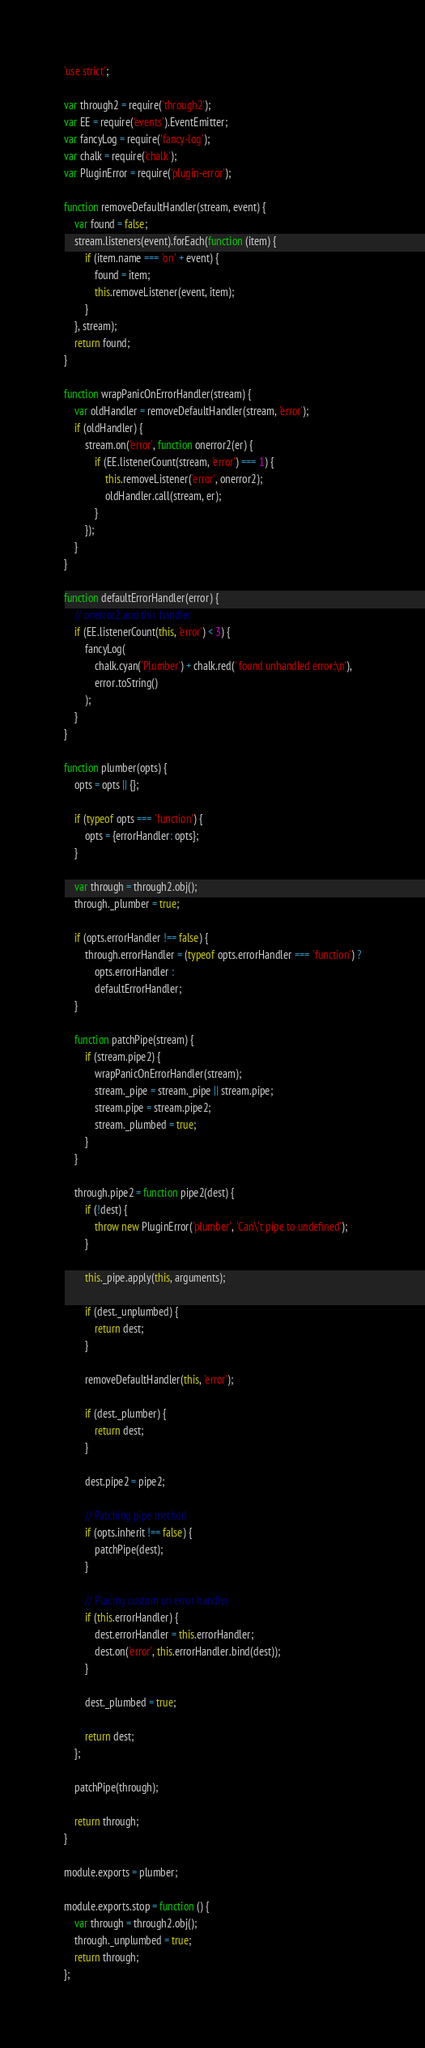Convert code to text. <code><loc_0><loc_0><loc_500><loc_500><_JavaScript_>'use strict';

var through2 = require('through2');
var EE = require('events').EventEmitter;
var fancyLog = require('fancy-log');
var chalk = require('chalk');
var PluginError = require('plugin-error');

function removeDefaultHandler(stream, event) {
	var found = false;
	stream.listeners(event).forEach(function (item) {
		if (item.name === 'on' + event) {
			found = item;
			this.removeListener(event, item);
		}
	}, stream);
	return found;
}

function wrapPanicOnErrorHandler(stream) {
	var oldHandler = removeDefaultHandler(stream, 'error');
	if (oldHandler) {
		stream.on('error', function onerror2(er) {
			if (EE.listenerCount(stream, 'error') === 1) {
				this.removeListener('error', onerror2);
				oldHandler.call(stream, er);
			}
		});
	}
}

function defaultErrorHandler(error) {
	// onerror2 and this handler
	if (EE.listenerCount(this, 'error') < 3) {
		fancyLog(
			chalk.cyan('Plumber') + chalk.red(' found unhandled error:\n'),
			error.toString()
		);
	}
}

function plumber(opts) {
	opts = opts || {};

	if (typeof opts === 'function') {
		opts = {errorHandler: opts};
	}

	var through = through2.obj();
	through._plumber = true;

	if (opts.errorHandler !== false) {
		through.errorHandler = (typeof opts.errorHandler === 'function') ?
			opts.errorHandler :
			defaultErrorHandler;
	}

	function patchPipe(stream) {
		if (stream.pipe2) {
			wrapPanicOnErrorHandler(stream);
			stream._pipe = stream._pipe || stream.pipe;
			stream.pipe = stream.pipe2;
			stream._plumbed = true;
		}
	}

	through.pipe2 = function pipe2(dest) {
		if (!dest) {
			throw new PluginError('plumber', 'Can\'t pipe to undefined');
		}

		this._pipe.apply(this, arguments);

		if (dest._unplumbed) {
			return dest;
		}

		removeDefaultHandler(this, 'error');

		if (dest._plumber) {
			return dest;
		}

		dest.pipe2 = pipe2;

		// Patching pipe method
		if (opts.inherit !== false) {
			patchPipe(dest);
		}

		// Placing custom on error handler
		if (this.errorHandler) {
			dest.errorHandler = this.errorHandler;
			dest.on('error', this.errorHandler.bind(dest));
		}

		dest._plumbed = true;

		return dest;
	};

	patchPipe(through);

	return through;
}

module.exports = plumber;

module.exports.stop = function () {
	var through = through2.obj();
	through._unplumbed = true;
	return through;
};
</code> 